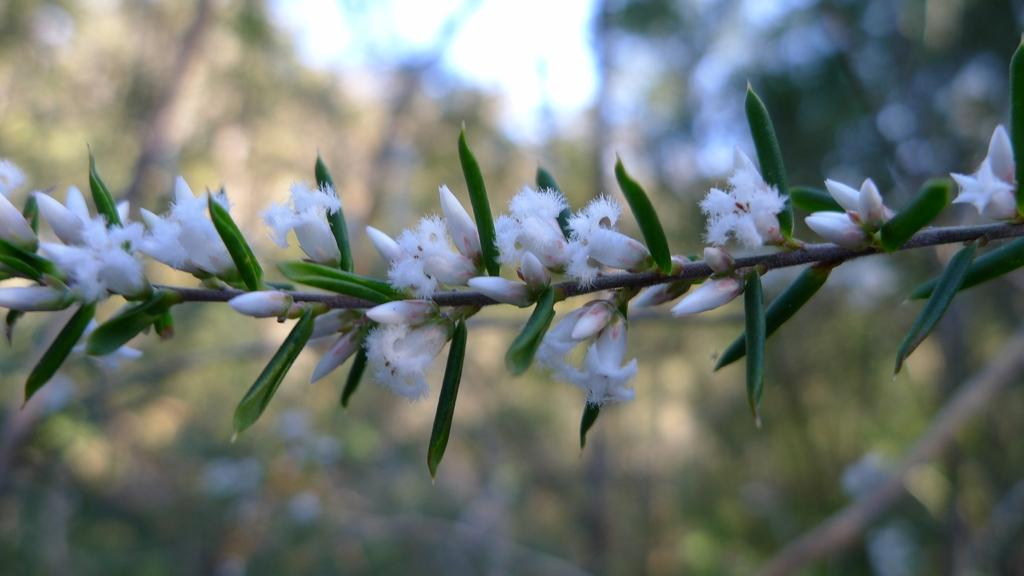What type of plant life is visible in the image? There are flowers and leaves of a plant in the image. Can you describe the background of the image? The background of the image is blurry. What type of soup is being served by the doctor in the image? There is no doctor or soup present in the image; it features flowers and leaves of a plant. Can you tell me how many jellyfish are swimming in the background of the image? There are no jellyfish present in the image; it features a blurry background with flowers and leaves of a plant. 